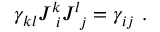<formula> <loc_0><loc_0><loc_500><loc_500>\gamma _ { k l } J _ { \ i } ^ { k } J _ { \ j } ^ { l } = \gamma _ { i j } \ .</formula> 